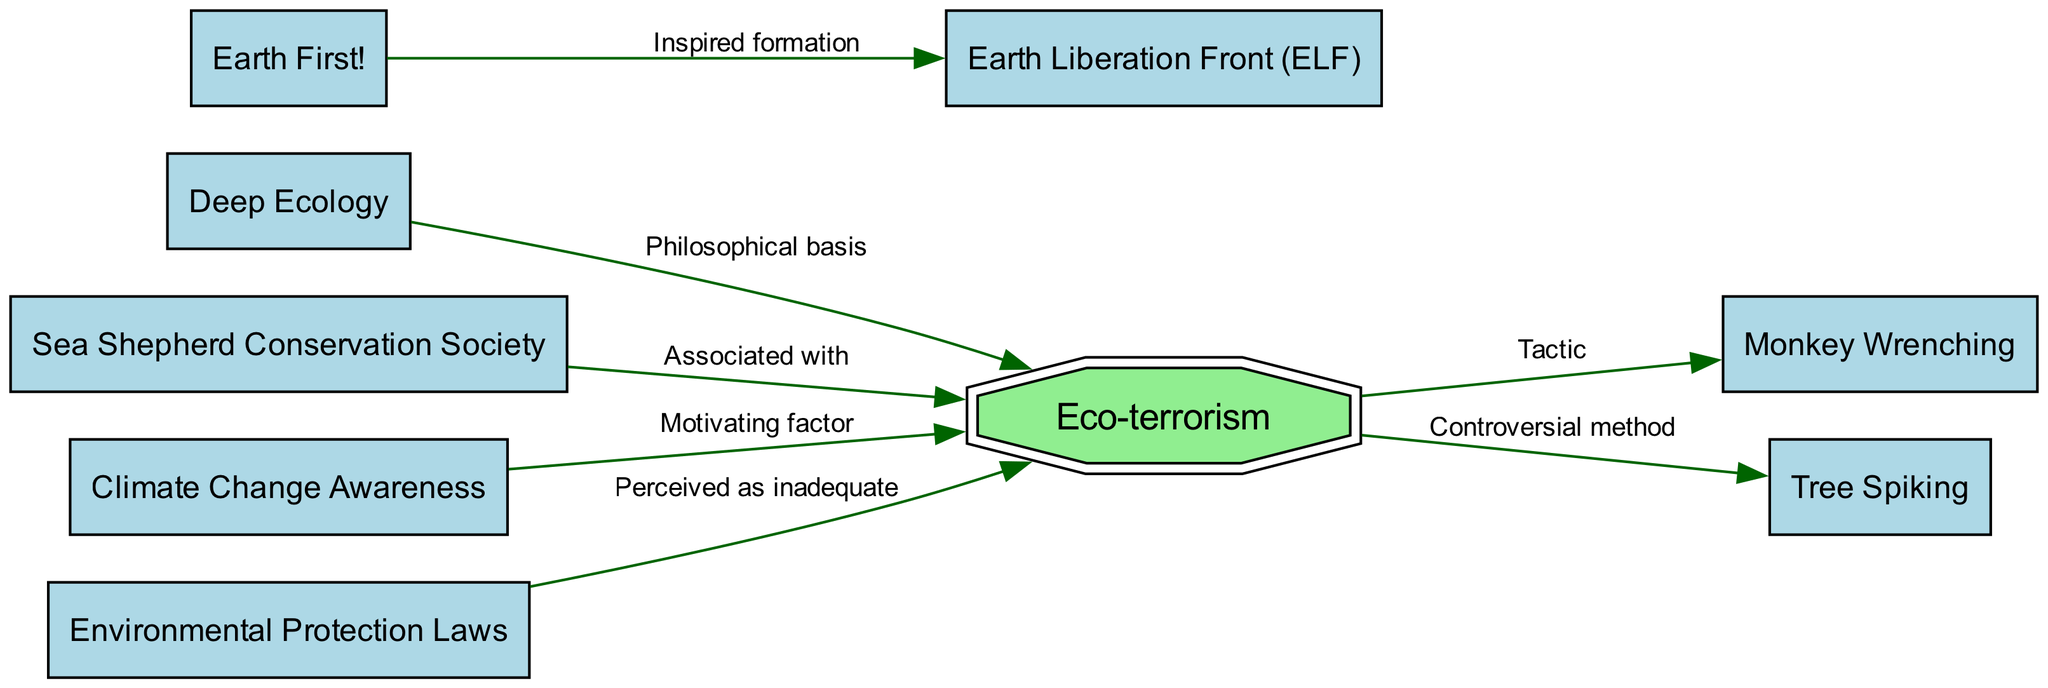What is the main subject represented in the diagram? The main subject of the diagram is eco-terrorism, which is represented as the central node, highlighted in a doubleoctagon shape and labeled "Eco-terrorism".
Answer: Eco-terrorism How many nodes are in the diagram? The diagram contains a total of 8 nodes, each representing different aspects or movements related to eco-terrorism and environmental activism.
Answer: 8 Which tactic is directly associated with eco-terrorism in the diagram? The diagram indicates that "Monkey Wrenching" is associated with eco-terrorism, as shown by a directed edge labeled "Tactic" connecting the two nodes.
Answer: Monkey Wrenching What is the relationship between Earth First! and ELF? The relationship is that Earth First! inspired the formation of the Earth Liberation Front (ELF), indicated by the directed edge labeled "Inspired formation".
Answer: Inspired formation What motivates eco-terrorism according to the diagram? The diagram shows that "Climate Change Awareness" acts as a motivating factor for eco-terrorism, represented by an edge from the climate change node to the eco-terrorism node.
Answer: Climate Change Awareness What method is considered controversial within eco-terrorism? The method labeled "Tree Spiking" is considered controversial within eco-terrorism as indicated by the edge connecting eco-terrorism and tree spiking with the label "Controversial method".
Answer: Tree Spiking Explain how Deep Ecology relates to eco-terrorism. Deep Ecology provides a philosophical basis for eco-terrorism, shown by the directed edge from the Deep Ecology node to the eco-terrorism node labeled "Philosophical basis", which signifies its foundational influence on eco-terrorism beliefs.
Answer: Philosophical basis What are environmental protection laws perceived as, in relation to eco-terrorism? The diagram indicates that environmental protection laws are perceived as inadequate, illustrated by an edge from the environmental laws node to the eco-terrorism node labeled "Perceived as inadequate".
Answer: Inadequate Which organization is associated with eco-terrorism in the diagram? The Sea Shepherd Conservation Society is associated with eco-terrorism, as indicated by the directed edge from the sea shepherd node to the eco-terrorism node, labeled "Associated with".
Answer: Sea Shepherd Conservation Society 